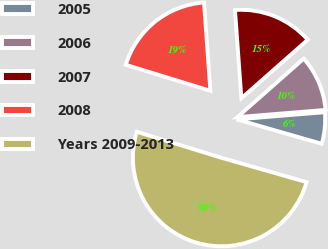<chart> <loc_0><loc_0><loc_500><loc_500><pie_chart><fcel>2005<fcel>2006<fcel>2007<fcel>2008<fcel>Years 2009-2013<nl><fcel>5.74%<fcel>10.2%<fcel>14.65%<fcel>19.11%<fcel>50.29%<nl></chart> 